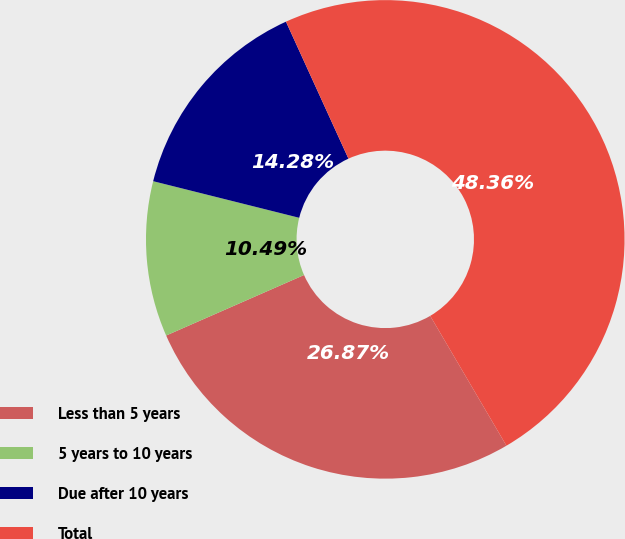Convert chart. <chart><loc_0><loc_0><loc_500><loc_500><pie_chart><fcel>Less than 5 years<fcel>5 years to 10 years<fcel>Due after 10 years<fcel>Total<nl><fcel>26.87%<fcel>10.49%<fcel>14.28%<fcel>48.36%<nl></chart> 